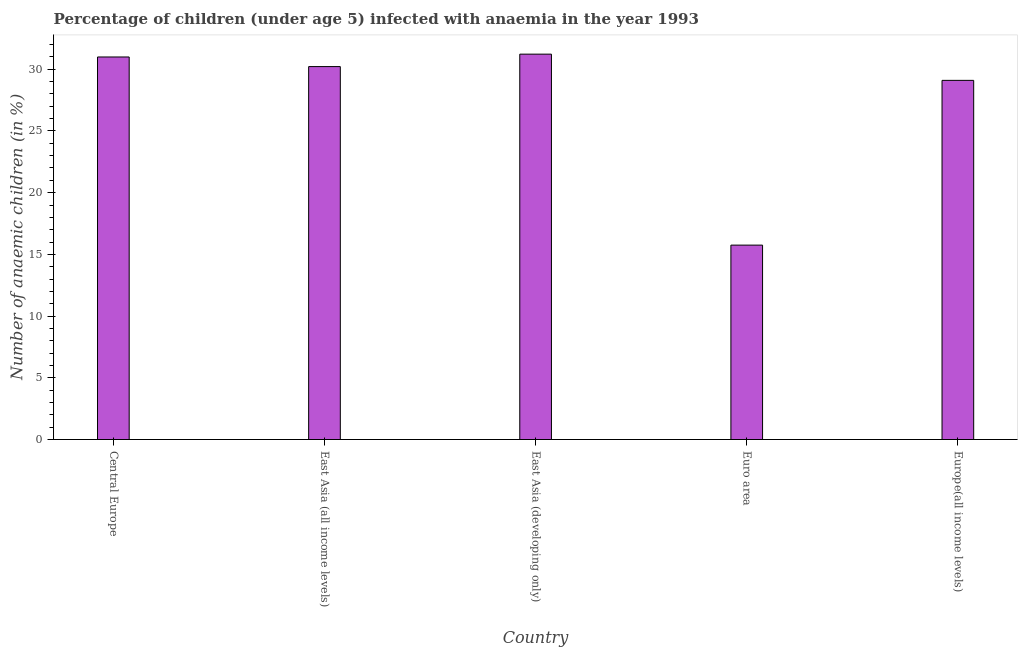What is the title of the graph?
Your response must be concise. Percentage of children (under age 5) infected with anaemia in the year 1993. What is the label or title of the Y-axis?
Your answer should be compact. Number of anaemic children (in %). What is the number of anaemic children in Central Europe?
Make the answer very short. 31. Across all countries, what is the maximum number of anaemic children?
Your answer should be very brief. 31.23. Across all countries, what is the minimum number of anaemic children?
Keep it short and to the point. 15.75. In which country was the number of anaemic children maximum?
Offer a terse response. East Asia (developing only). What is the sum of the number of anaemic children?
Provide a succinct answer. 137.29. What is the difference between the number of anaemic children in East Asia (developing only) and Europe(all income levels)?
Keep it short and to the point. 2.12. What is the average number of anaemic children per country?
Provide a short and direct response. 27.46. What is the median number of anaemic children?
Your response must be concise. 30.22. In how many countries, is the number of anaemic children greater than 28 %?
Give a very brief answer. 4. What is the ratio of the number of anaemic children in Euro area to that in Europe(all income levels)?
Offer a terse response. 0.54. Is the number of anaemic children in Euro area less than that in Europe(all income levels)?
Provide a short and direct response. Yes. Is the difference between the number of anaemic children in Central Europe and East Asia (all income levels) greater than the difference between any two countries?
Offer a very short reply. No. What is the difference between the highest and the second highest number of anaemic children?
Your response must be concise. 0.23. What is the difference between the highest and the lowest number of anaemic children?
Keep it short and to the point. 15.47. How many bars are there?
Keep it short and to the point. 5. How many countries are there in the graph?
Provide a succinct answer. 5. What is the difference between two consecutive major ticks on the Y-axis?
Your response must be concise. 5. Are the values on the major ticks of Y-axis written in scientific E-notation?
Your answer should be very brief. No. What is the Number of anaemic children (in %) in Central Europe?
Your answer should be very brief. 31. What is the Number of anaemic children (in %) of East Asia (all income levels)?
Keep it short and to the point. 30.22. What is the Number of anaemic children (in %) in East Asia (developing only)?
Give a very brief answer. 31.23. What is the Number of anaemic children (in %) of Euro area?
Your response must be concise. 15.75. What is the Number of anaemic children (in %) of Europe(all income levels)?
Offer a terse response. 29.1. What is the difference between the Number of anaemic children (in %) in Central Europe and East Asia (all income levels)?
Provide a short and direct response. 0.78. What is the difference between the Number of anaemic children (in %) in Central Europe and East Asia (developing only)?
Your answer should be very brief. -0.23. What is the difference between the Number of anaemic children (in %) in Central Europe and Euro area?
Your answer should be very brief. 15.24. What is the difference between the Number of anaemic children (in %) in Central Europe and Europe(all income levels)?
Offer a terse response. 1.9. What is the difference between the Number of anaemic children (in %) in East Asia (all income levels) and East Asia (developing only)?
Your response must be concise. -1.01. What is the difference between the Number of anaemic children (in %) in East Asia (all income levels) and Euro area?
Provide a succinct answer. 14.47. What is the difference between the Number of anaemic children (in %) in East Asia (all income levels) and Europe(all income levels)?
Your response must be concise. 1.12. What is the difference between the Number of anaemic children (in %) in East Asia (developing only) and Euro area?
Offer a very short reply. 15.47. What is the difference between the Number of anaemic children (in %) in East Asia (developing only) and Europe(all income levels)?
Provide a succinct answer. 2.13. What is the difference between the Number of anaemic children (in %) in Euro area and Europe(all income levels)?
Make the answer very short. -13.35. What is the ratio of the Number of anaemic children (in %) in Central Europe to that in East Asia (all income levels)?
Keep it short and to the point. 1.03. What is the ratio of the Number of anaemic children (in %) in Central Europe to that in Euro area?
Ensure brevity in your answer.  1.97. What is the ratio of the Number of anaemic children (in %) in Central Europe to that in Europe(all income levels)?
Your answer should be compact. 1.06. What is the ratio of the Number of anaemic children (in %) in East Asia (all income levels) to that in East Asia (developing only)?
Your response must be concise. 0.97. What is the ratio of the Number of anaemic children (in %) in East Asia (all income levels) to that in Euro area?
Provide a short and direct response. 1.92. What is the ratio of the Number of anaemic children (in %) in East Asia (all income levels) to that in Europe(all income levels)?
Make the answer very short. 1.04. What is the ratio of the Number of anaemic children (in %) in East Asia (developing only) to that in Euro area?
Offer a very short reply. 1.98. What is the ratio of the Number of anaemic children (in %) in East Asia (developing only) to that in Europe(all income levels)?
Give a very brief answer. 1.07. What is the ratio of the Number of anaemic children (in %) in Euro area to that in Europe(all income levels)?
Make the answer very short. 0.54. 